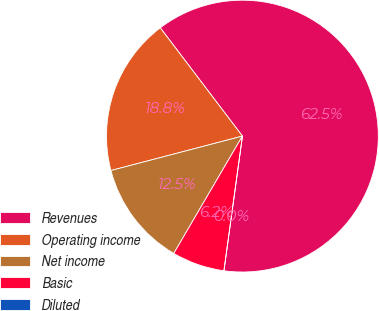Convert chart. <chart><loc_0><loc_0><loc_500><loc_500><pie_chart><fcel>Revenues<fcel>Operating income<fcel>Net income<fcel>Basic<fcel>Diluted<nl><fcel>62.5%<fcel>18.75%<fcel>12.5%<fcel>6.25%<fcel>0.0%<nl></chart> 